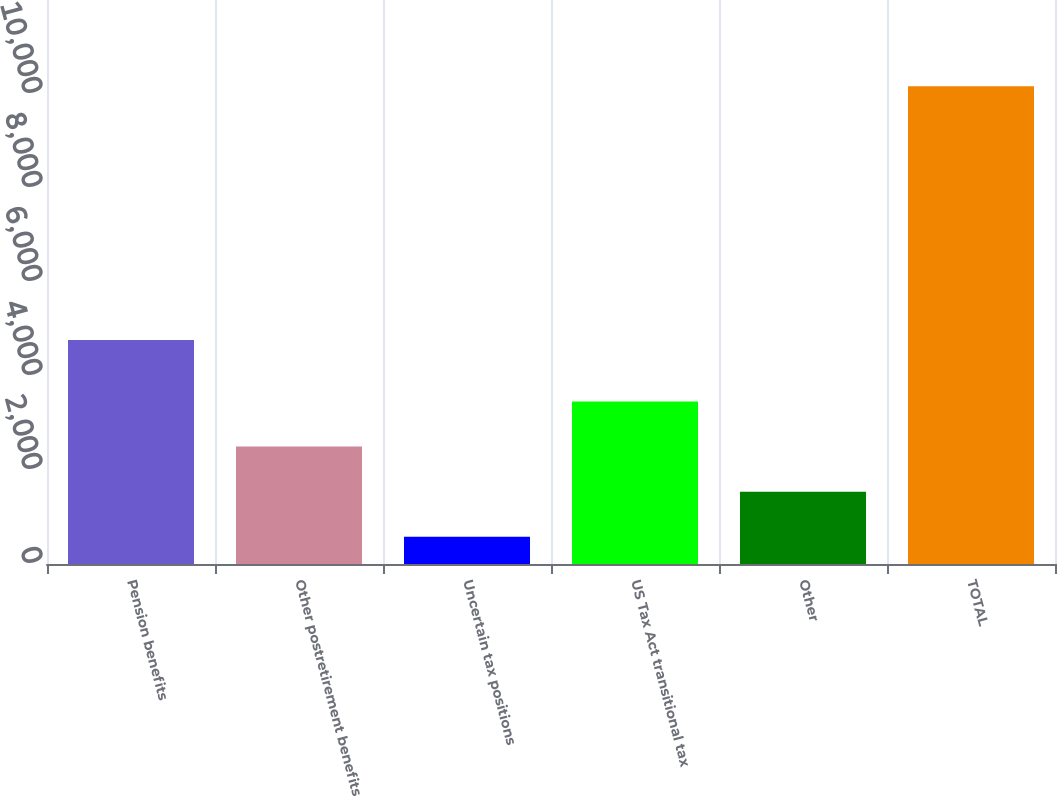Convert chart. <chart><loc_0><loc_0><loc_500><loc_500><bar_chart><fcel>Pension benefits<fcel>Other postretirement benefits<fcel>Uncertain tax positions<fcel>US Tax Act transitional tax<fcel>Other<fcel>TOTAL<nl><fcel>4768<fcel>2497.6<fcel>581<fcel>3455.9<fcel>1539.3<fcel>10164<nl></chart> 